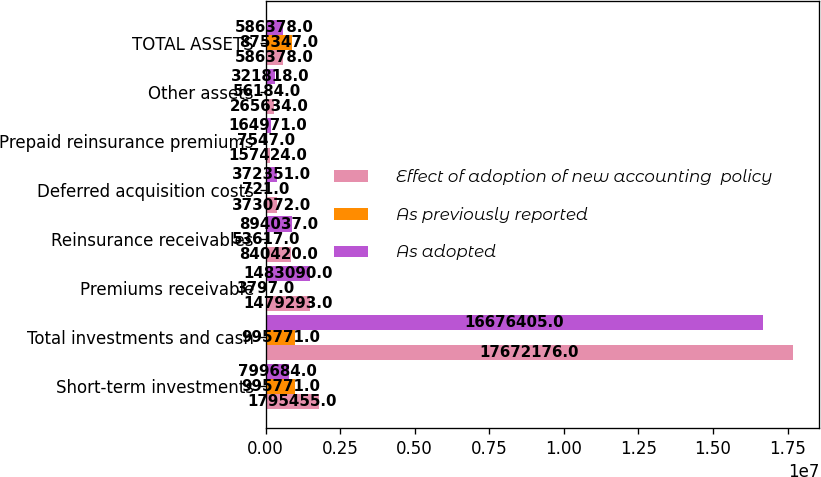<chart> <loc_0><loc_0><loc_500><loc_500><stacked_bar_chart><ecel><fcel>Short-term investments<fcel>Total investments and cash<fcel>Premiums receivable<fcel>Reinsurance receivables<fcel>Deferred acquisition costs<fcel>Prepaid reinsurance premiums<fcel>Other assets<fcel>TOTAL ASSETS<nl><fcel>Effect of adoption of new accounting  policy<fcel>1.79546e+06<fcel>1.76722e+07<fcel>1.47929e+06<fcel>840420<fcel>373072<fcel>157424<fcel>265634<fcel>586378<nl><fcel>As previously reported<fcel>995771<fcel>995771<fcel>3797<fcel>53617<fcel>721<fcel>7547<fcel>56184<fcel>875347<nl><fcel>As adopted<fcel>799684<fcel>1.66764e+07<fcel>1.48309e+06<fcel>894037<fcel>372351<fcel>164971<fcel>321818<fcel>586378<nl></chart> 